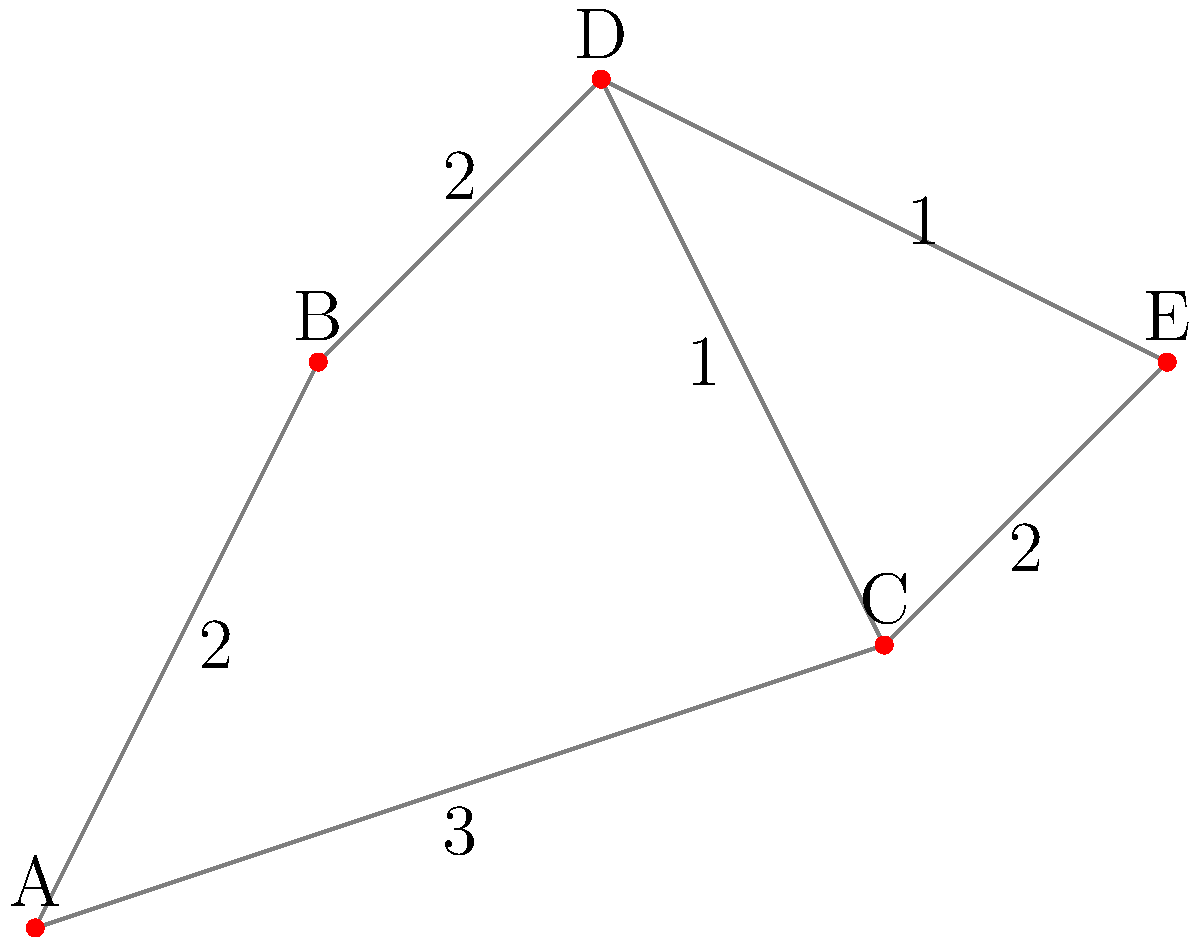In the night sky, you observe five bright planets represented by nodes A, B, C, D, and E. The edges between the nodes represent the apparent angular distance between the planets, measured in arbitrary units. What is the shortest path from planet A to planet E, and what is its total length? To find the shortest path from planet A to planet E, we can use Dijkstra's algorithm or simply examine all possible paths:

1. Path A-B-D-E:
   Length = 2 + 2 + 1 = 5 units

2. Path A-C-D-E:
   Length = 3 + 1 + 1 = 5 units

3. Path A-C-E:
   Length = 3 + 2 = 5 units

All three paths have the same length of 5 units. However, the path A-C-E has fewer intermediate stops, making it the most efficient route for stargazing.

Step-by-step calculation for A-C-E:
1. Distance from A to C: 3 units
2. Distance from C to E: 2 units
3. Total distance: 3 + 2 = 5 units

Therefore, the shortest path from planet A to planet E is A-C-E, with a total length of 5 units.
Answer: A-C-E, 5 units 